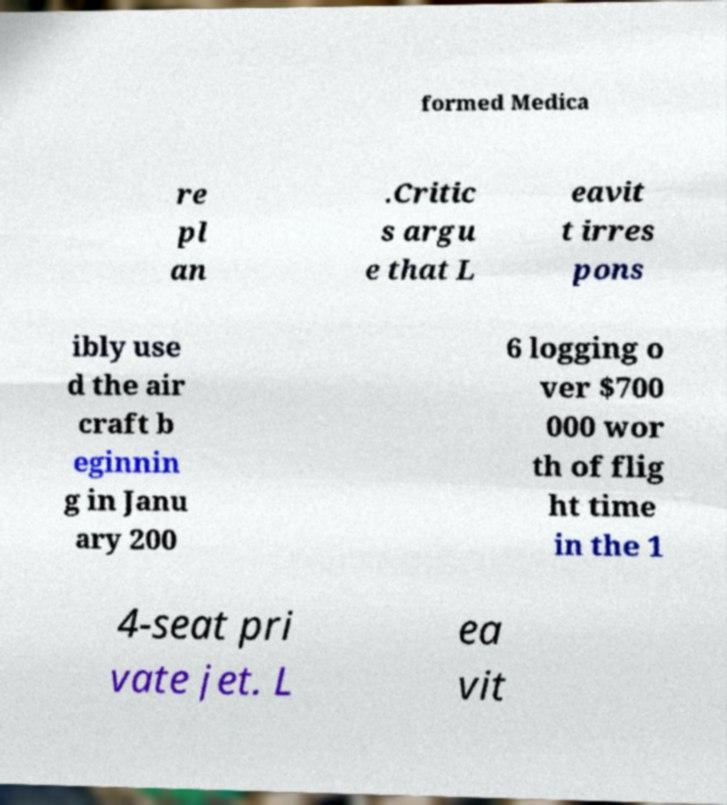There's text embedded in this image that I need extracted. Can you transcribe it verbatim? formed Medica re pl an .Critic s argu e that L eavit t irres pons ibly use d the air craft b eginnin g in Janu ary 200 6 logging o ver $700 000 wor th of flig ht time in the 1 4-seat pri vate jet. L ea vit 